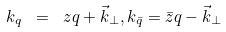<formula> <loc_0><loc_0><loc_500><loc_500>k _ { q } \ = \ z q + \vec { k } _ { \perp } , k _ { \bar { q } } = \bar { z } q - \vec { k } _ { \perp }</formula> 